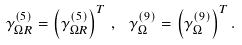<formula> <loc_0><loc_0><loc_500><loc_500>\gamma _ { \Omega R } ^ { ( 5 ) } = \left ( \gamma _ { \Omega R } ^ { ( 5 ) } \right ) ^ { T } \, , \, \ \gamma _ { \Omega } ^ { ( 9 ) } = \left ( \gamma _ { \Omega } ^ { ( 9 ) } \right ) ^ { T } .</formula> 